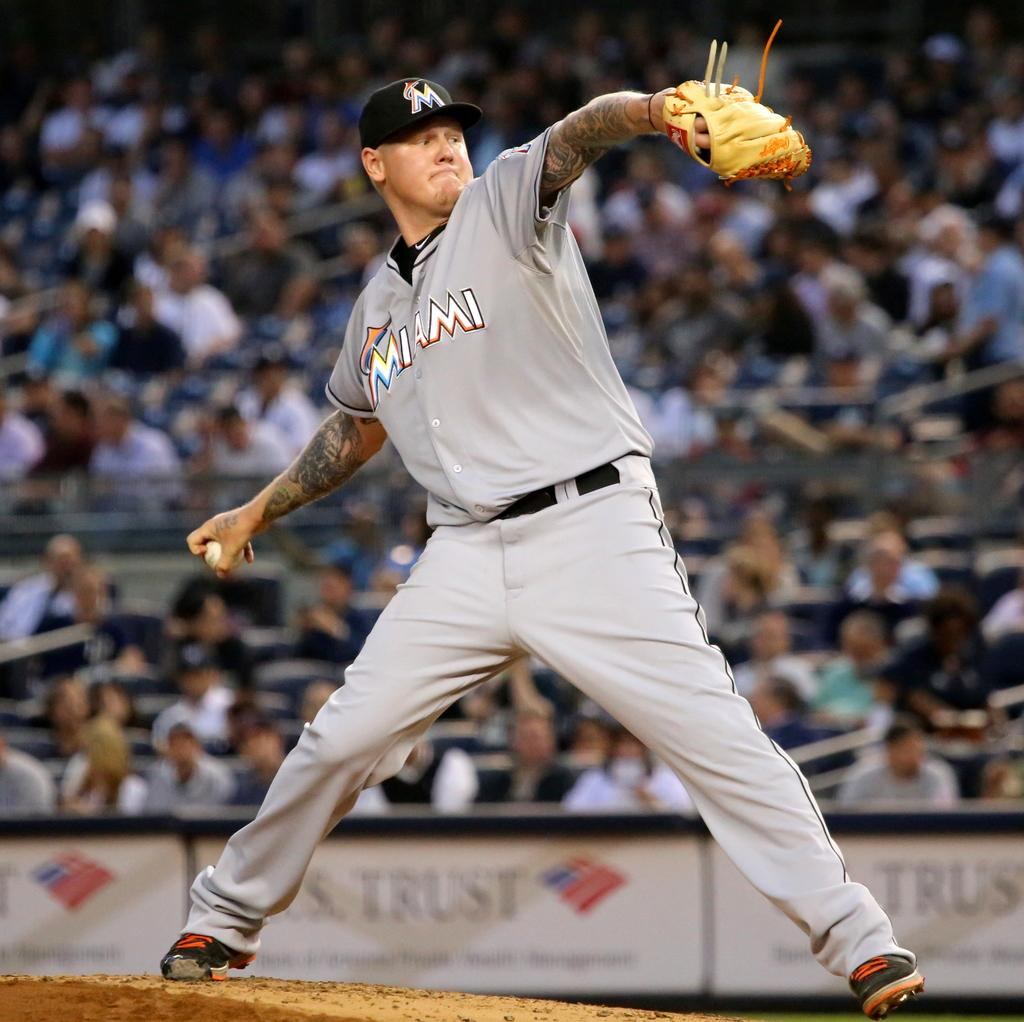<image>
Present a compact description of the photo's key features. A Miami pitcher throws a pitch in front of a stadium full of people. 